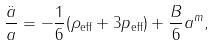<formula> <loc_0><loc_0><loc_500><loc_500>\frac { \ddot { a } } { a } = - \frac { 1 } { 6 } ( \rho _ { \text {eff} } + 3 p _ { \text {eff} } ) + \frac { B } { 6 } a ^ { m } ,</formula> 